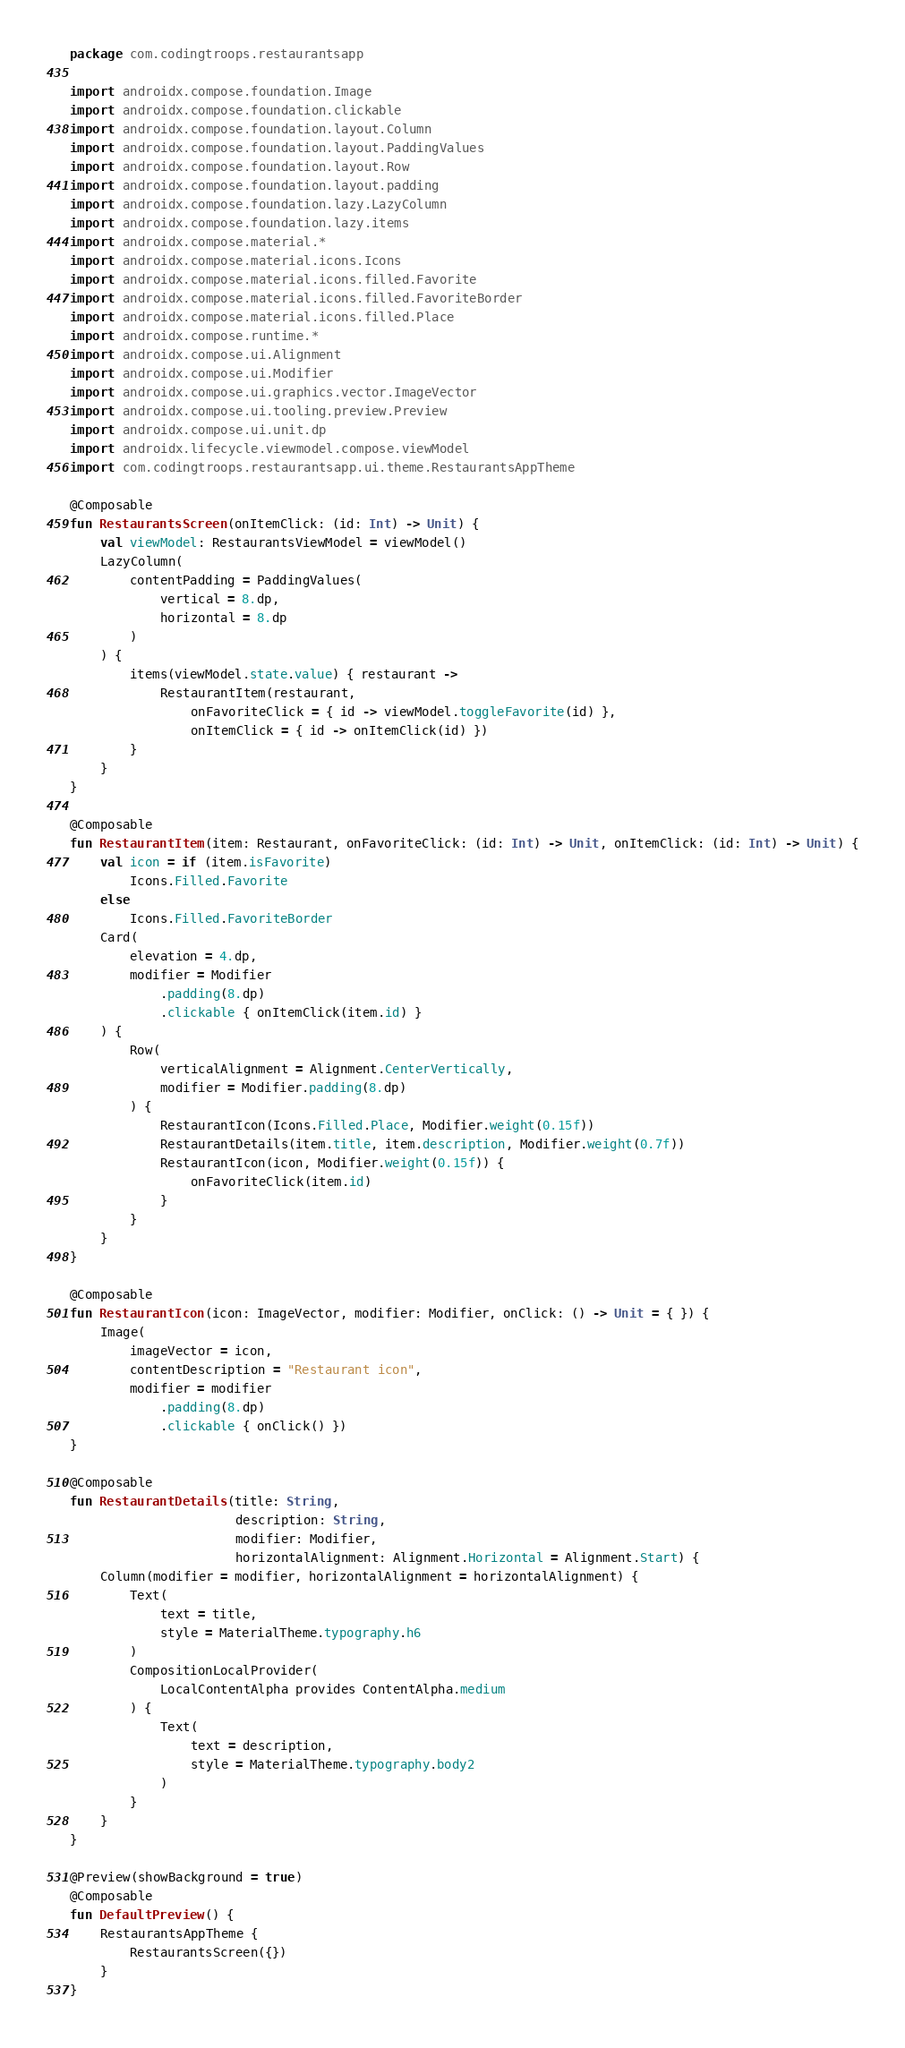Convert code to text. <code><loc_0><loc_0><loc_500><loc_500><_Kotlin_>package com.codingtroops.restaurantsapp

import androidx.compose.foundation.Image
import androidx.compose.foundation.clickable
import androidx.compose.foundation.layout.Column
import androidx.compose.foundation.layout.PaddingValues
import androidx.compose.foundation.layout.Row
import androidx.compose.foundation.layout.padding
import androidx.compose.foundation.lazy.LazyColumn
import androidx.compose.foundation.lazy.items
import androidx.compose.material.*
import androidx.compose.material.icons.Icons
import androidx.compose.material.icons.filled.Favorite
import androidx.compose.material.icons.filled.FavoriteBorder
import androidx.compose.material.icons.filled.Place
import androidx.compose.runtime.*
import androidx.compose.ui.Alignment
import androidx.compose.ui.Modifier
import androidx.compose.ui.graphics.vector.ImageVector
import androidx.compose.ui.tooling.preview.Preview
import androidx.compose.ui.unit.dp
import androidx.lifecycle.viewmodel.compose.viewModel
import com.codingtroops.restaurantsapp.ui.theme.RestaurantsAppTheme

@Composable
fun RestaurantsScreen(onItemClick: (id: Int) -> Unit) {
    val viewModel: RestaurantsViewModel = viewModel()
    LazyColumn(
        contentPadding = PaddingValues(
            vertical = 8.dp,
            horizontal = 8.dp
        )
    ) {
        items(viewModel.state.value) { restaurant ->
            RestaurantItem(restaurant,
                onFavoriteClick = { id -> viewModel.toggleFavorite(id) },
                onItemClick = { id -> onItemClick(id) })
        }
    }
}

@Composable
fun RestaurantItem(item: Restaurant, onFavoriteClick: (id: Int) -> Unit, onItemClick: (id: Int) -> Unit) {
    val icon = if (item.isFavorite)
        Icons.Filled.Favorite
    else
        Icons.Filled.FavoriteBorder
    Card(
        elevation = 4.dp,
        modifier = Modifier
            .padding(8.dp)
            .clickable { onItemClick(item.id) }
    ) {
        Row(
            verticalAlignment = Alignment.CenterVertically,
            modifier = Modifier.padding(8.dp)
        ) {
            RestaurantIcon(Icons.Filled.Place, Modifier.weight(0.15f))
            RestaurantDetails(item.title, item.description, Modifier.weight(0.7f))
            RestaurantIcon(icon, Modifier.weight(0.15f)) {
                onFavoriteClick(item.id)
            }
        }
    }
}

@Composable
fun RestaurantIcon(icon: ImageVector, modifier: Modifier, onClick: () -> Unit = { }) {
    Image(
        imageVector = icon,
        contentDescription = "Restaurant icon",
        modifier = modifier
            .padding(8.dp)
            .clickable { onClick() })
}

@Composable
fun RestaurantDetails(title: String,
                      description: String,
                      modifier: Modifier,
                      horizontalAlignment: Alignment.Horizontal = Alignment.Start) {
    Column(modifier = modifier, horizontalAlignment = horizontalAlignment) {
        Text(
            text = title,
            style = MaterialTheme.typography.h6
        )
        CompositionLocalProvider(
            LocalContentAlpha provides ContentAlpha.medium
        ) {
            Text(
                text = description,
                style = MaterialTheme.typography.body2
            )
        }
    }
}

@Preview(showBackground = true)
@Composable
fun DefaultPreview() {
    RestaurantsAppTheme {
        RestaurantsScreen({})
    }
}</code> 